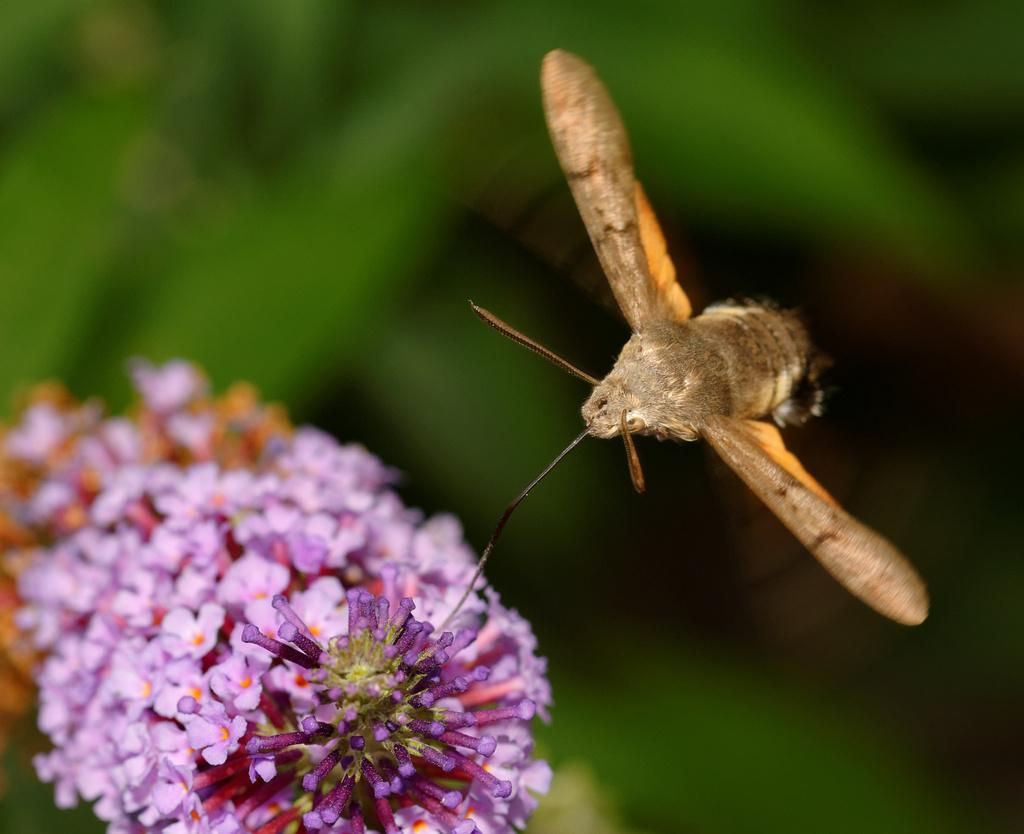What type of insect is present in the image? There is a moth in the image. What other living organisms can be seen in the image? There are flowers in the image. What is the dominant color in the background of the image? The background color is green. How would you describe the clarity of the image? The image appears to be blurry. Can you tell me how many docks are visible in the image? There are no docks present in the image. What type of digestion system does the goose have in the image? There is no goose present in the image, so it is not possible to determine its digestion system. 